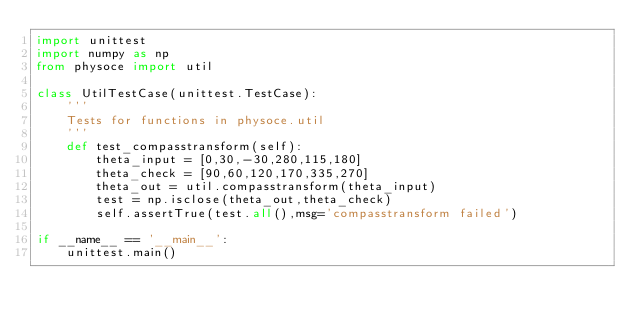<code> <loc_0><loc_0><loc_500><loc_500><_Python_>import unittest
import numpy as np
from physoce import util

class UtilTestCase(unittest.TestCase):
    '''
    Tests for functions in physoce.util
    '''
    def test_compasstransform(self):
        theta_input = [0,30,-30,280,115,180]
        theta_check = [90,60,120,170,335,270]
        theta_out = util.compasstransform(theta_input)
        test = np.isclose(theta_out,theta_check)
        self.assertTrue(test.all(),msg='compasstransform failed')
        
if __name__ == '__main__':
    unittest.main()

</code> 